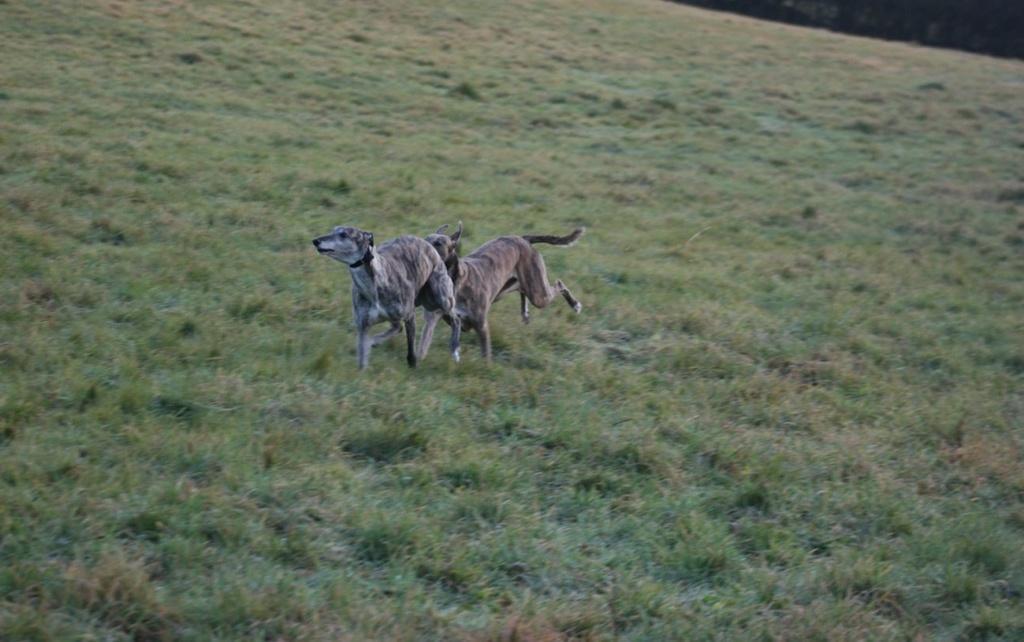Describe this image in one or two sentences. In the image in the center we can see two dogs. In the background we can see grass. 